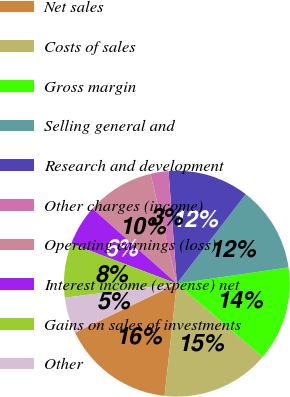Convert chart to OTSL. <chart><loc_0><loc_0><loc_500><loc_500><pie_chart><fcel>Net sales<fcel>Costs of sales<fcel>Gross margin<fcel>Selling general and<fcel>Research and development<fcel>Other charges (income)<fcel>Operating earnings (loss)<fcel>Interest income (expense) net<fcel>Gains on sales of investments<fcel>Other<nl><fcel>16.13%<fcel>15.48%<fcel>13.55%<fcel>12.26%<fcel>11.61%<fcel>2.58%<fcel>9.68%<fcel>5.81%<fcel>7.74%<fcel>5.16%<nl></chart> 